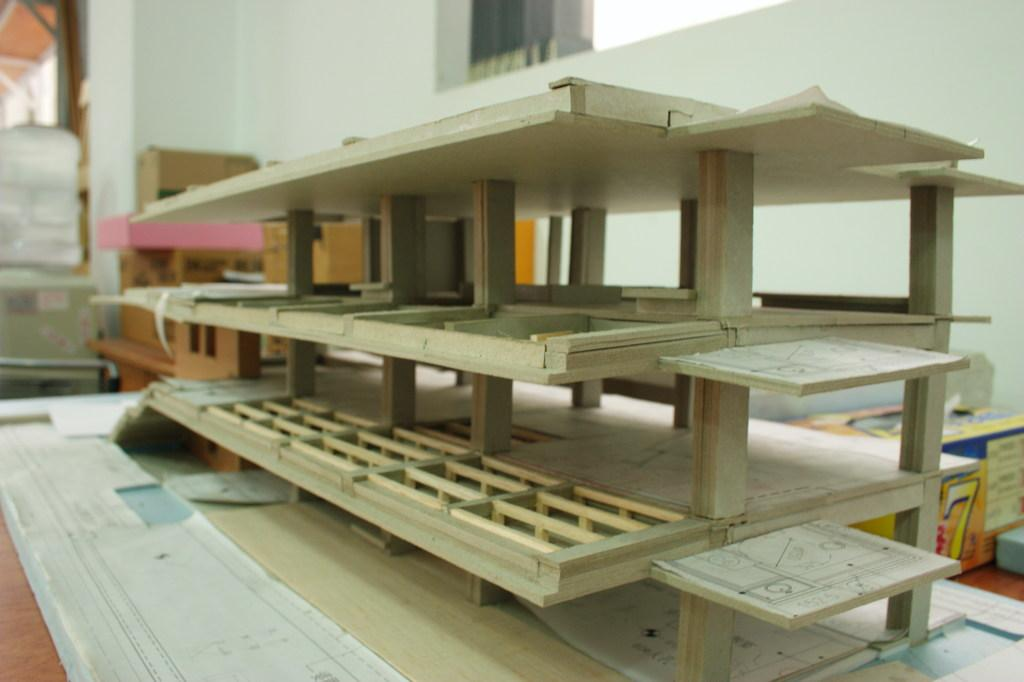What is the main subject of the image? There is a scale model in the image. What can be seen behind the scale model? There are cartons at the back of the image. What is the background of the image made of? There is a wall at the back of the image. How many trees are visible in the image? There are no trees visible in the image; the background consists of a wall and cartons. 